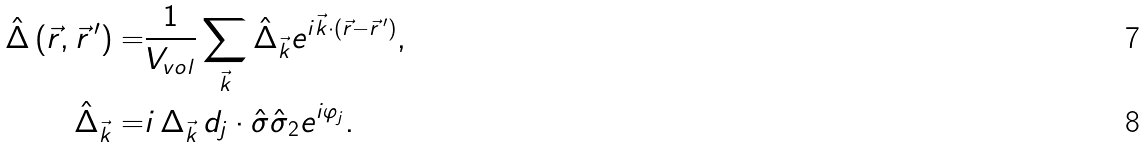<formula> <loc_0><loc_0><loc_500><loc_500>\hat { \Delta } \left ( \vec { r } , \vec { r } \, ^ { \prime } \right ) = & \frac { 1 } { V _ { v o l } } \sum _ { \vec { k } } \hat { \Delta } _ { \vec { k } } e ^ { i \vec { k } \cdot ( \vec { r } - \vec { r } \, ^ { \prime } ) } , \\ \hat { \Delta } _ { \vec { k } } = & i \, \Delta _ { \vec { k } } \, d _ { j } \cdot \hat { \sigma } \hat { \sigma } _ { 2 } e ^ { i \varphi _ { j } } .</formula> 